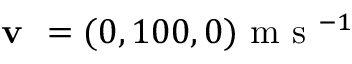Convert formula to latex. <formula><loc_0><loc_0><loc_500><loc_500>v = ( 0 , 1 0 0 , 0 ) m s ^ { - 1 }</formula> 